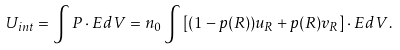<formula> <loc_0><loc_0><loc_500><loc_500>U _ { i n t } = \int { P } \cdot { E } d V = n _ { 0 } \int \left [ ( 1 - p ( { R } ) ) { u } _ { R } + p ( { R } ) { v } _ { R } \right ] \cdot { E } d V .</formula> 